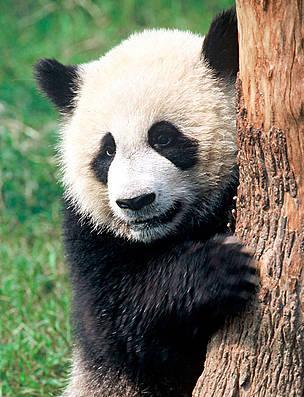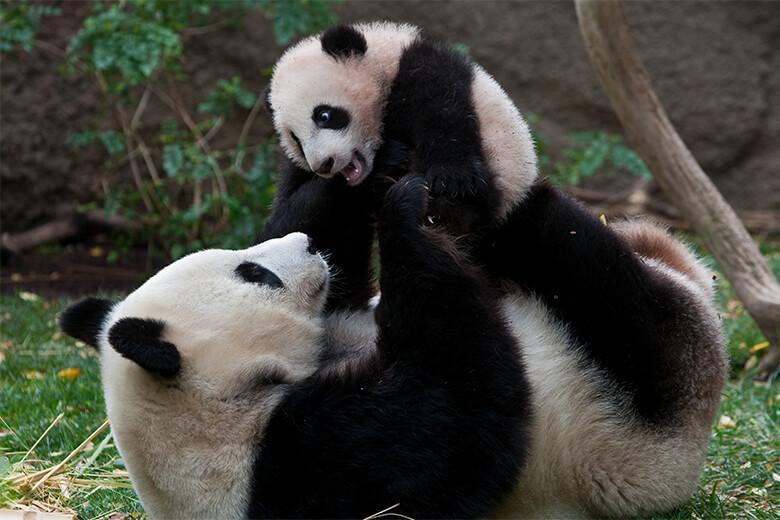The first image is the image on the left, the second image is the image on the right. Analyze the images presented: Is the assertion "At least one panda is eating." valid? Answer yes or no. No. The first image is the image on the left, the second image is the image on the right. Assess this claim about the two images: "There is at least one giant panda sitting in the grass and eating bamboo.". Correct or not? Answer yes or no. No. 